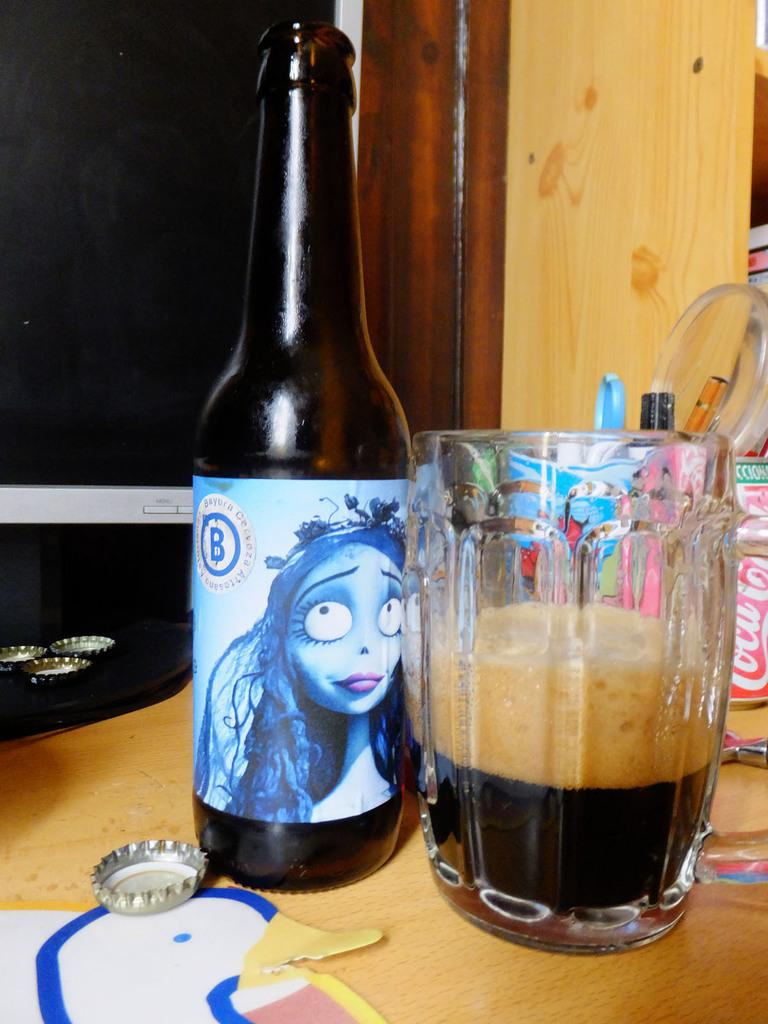<image>
Present a compact description of the photo's key features. Assorted beverages on a table including a beer bottle labeled B and a Coca Cola can 